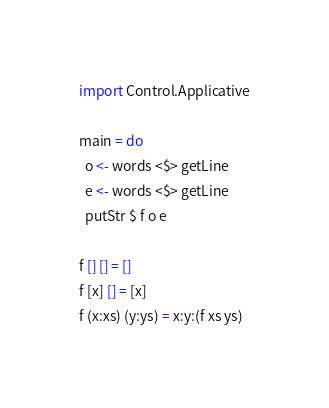Convert code to text. <code><loc_0><loc_0><loc_500><loc_500><_Haskell_>import Control.Applicative
 
main = do 
  o <- words <$> getLine
  e <- words <$> getLine
  putStr $ f o e
 
f [] [] = []
f [x] [] = [x]
f (x:xs) (y:ys) = x:y:(f xs ys)</code> 